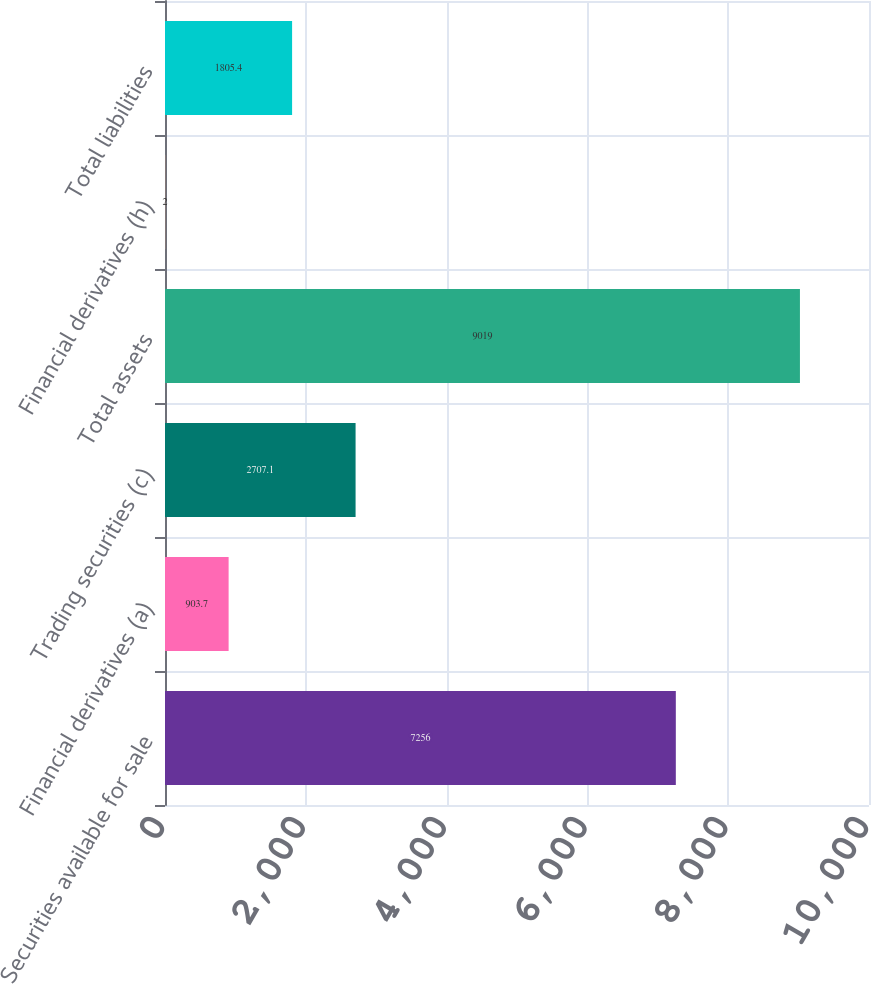<chart> <loc_0><loc_0><loc_500><loc_500><bar_chart><fcel>Securities available for sale<fcel>Financial derivatives (a)<fcel>Trading securities (c)<fcel>Total assets<fcel>Financial derivatives (h)<fcel>Total liabilities<nl><fcel>7256<fcel>903.7<fcel>2707.1<fcel>9019<fcel>2<fcel>1805.4<nl></chart> 